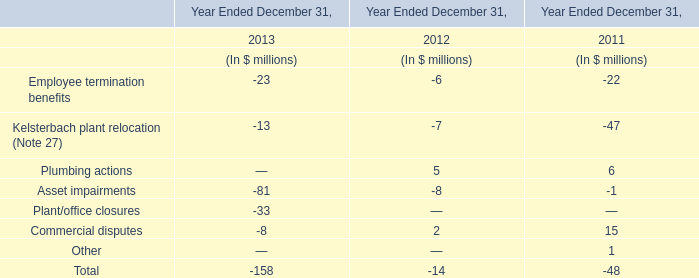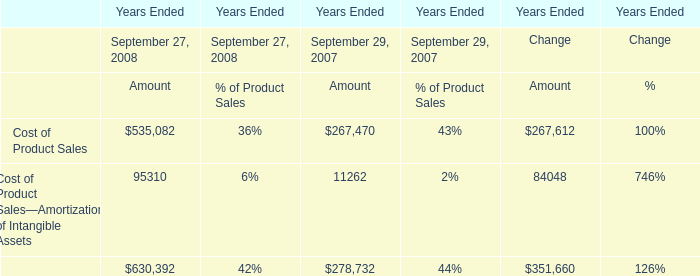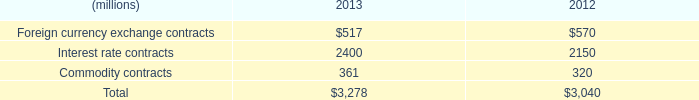What's the sum of Interest rate contracts of 2012, and Cost of Product Sales of Years Ended Change Amount ? 
Computations: (2150.0 + 267612.0)
Answer: 269762.0. 